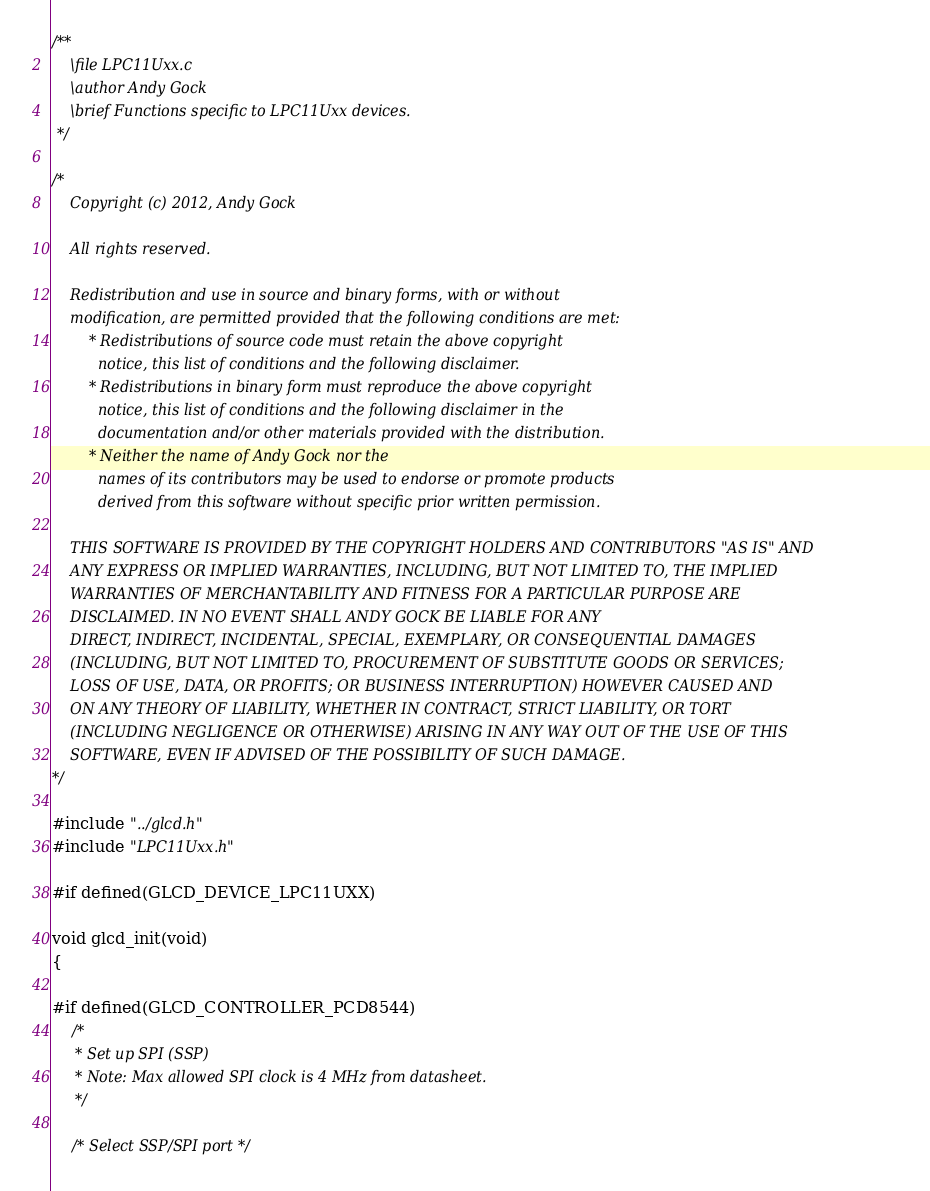<code> <loc_0><loc_0><loc_500><loc_500><_C_>/**
	\file LPC11Uxx.c
	\author Andy Gock
	\brief Functions specific to LPC11Uxx devices.
 */

/*
	Copyright (c) 2012, Andy Gock

	All rights reserved.

	Redistribution and use in source and binary forms, with or without
	modification, are permitted provided that the following conditions are met:
		* Redistributions of source code must retain the above copyright
		  notice, this list of conditions and the following disclaimer.
		* Redistributions in binary form must reproduce the above copyright
		  notice, this list of conditions and the following disclaimer in the
		  documentation and/or other materials provided with the distribution.
		* Neither the name of Andy Gock nor the
		  names of its contributors may be used to endorse or promote products
		  derived from this software without specific prior written permission.

	THIS SOFTWARE IS PROVIDED BY THE COPYRIGHT HOLDERS AND CONTRIBUTORS "AS IS" AND
	ANY EXPRESS OR IMPLIED WARRANTIES, INCLUDING, BUT NOT LIMITED TO, THE IMPLIED
	WARRANTIES OF MERCHANTABILITY AND FITNESS FOR A PARTICULAR PURPOSE ARE
	DISCLAIMED. IN NO EVENT SHALL ANDY GOCK BE LIABLE FOR ANY
	DIRECT, INDIRECT, INCIDENTAL, SPECIAL, EXEMPLARY, OR CONSEQUENTIAL DAMAGES
	(INCLUDING, BUT NOT LIMITED TO, PROCUREMENT OF SUBSTITUTE GOODS OR SERVICES;
	LOSS OF USE, DATA, OR PROFITS; OR BUSINESS INTERRUPTION) HOWEVER CAUSED AND
	ON ANY THEORY OF LIABILITY, WHETHER IN CONTRACT, STRICT LIABILITY, OR TORT
	(INCLUDING NEGLIGENCE OR OTHERWISE) ARISING IN ANY WAY OUT OF THE USE OF THIS
	SOFTWARE, EVEN IF ADVISED OF THE POSSIBILITY OF SUCH DAMAGE.
*/

#include "../glcd.h"
#include "LPC11Uxx.h"

#if defined(GLCD_DEVICE_LPC11UXX)

void glcd_init(void)
{

#if defined(GLCD_CONTROLLER_PCD8544)
	/*
	 * Set up SPI (SSP)
	 * Note: Max allowed SPI clock is 4 MHz from datasheet.
	 */

	/* Select SSP/SPI port */</code> 